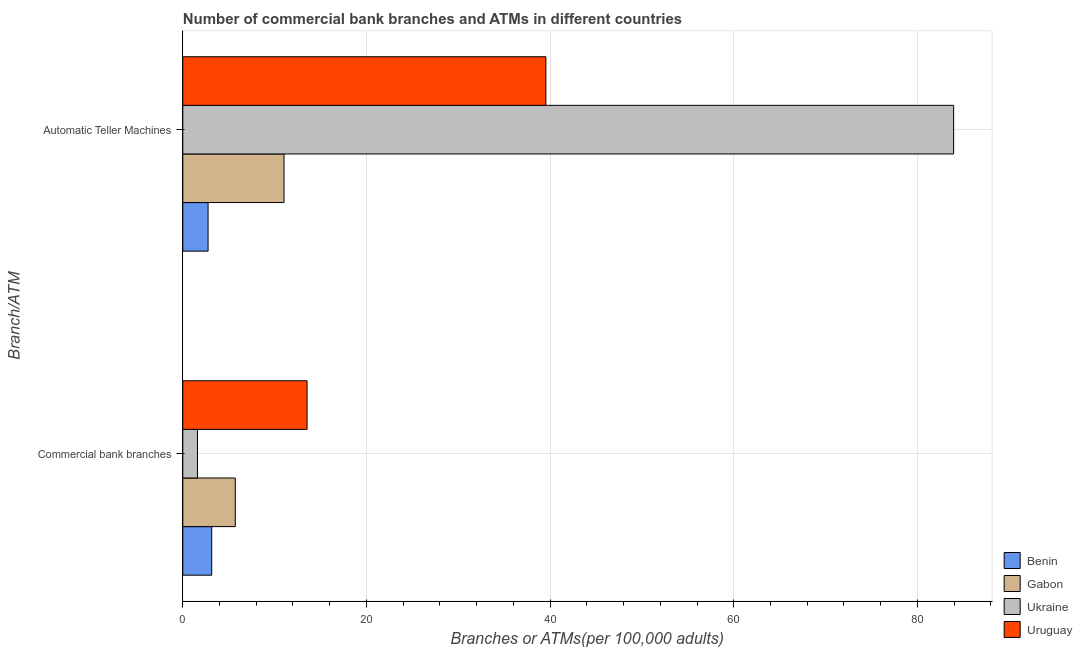How many different coloured bars are there?
Provide a succinct answer. 4. Are the number of bars on each tick of the Y-axis equal?
Keep it short and to the point. Yes. How many bars are there on the 2nd tick from the bottom?
Give a very brief answer. 4. What is the label of the 1st group of bars from the top?
Keep it short and to the point. Automatic Teller Machines. What is the number of atms in Benin?
Give a very brief answer. 2.75. Across all countries, what is the maximum number of atms?
Ensure brevity in your answer.  83.95. Across all countries, what is the minimum number of atms?
Provide a succinct answer. 2.75. In which country was the number of atms maximum?
Make the answer very short. Ukraine. In which country was the number of commercal bank branches minimum?
Your answer should be compact. Ukraine. What is the total number of commercal bank branches in the graph?
Your answer should be compact. 24. What is the difference between the number of atms in Gabon and that in Ukraine?
Give a very brief answer. -72.92. What is the difference between the number of atms in Benin and the number of commercal bank branches in Gabon?
Keep it short and to the point. -2.96. What is the average number of commercal bank branches per country?
Your answer should be very brief. 6. What is the difference between the number of commercal bank branches and number of atms in Uruguay?
Provide a short and direct response. -26.01. What is the ratio of the number of atms in Uruguay to that in Benin?
Offer a terse response. 14.36. Is the number of atms in Ukraine less than that in Uruguay?
Provide a short and direct response. No. What does the 3rd bar from the top in Commercial bank branches represents?
Keep it short and to the point. Gabon. What does the 4th bar from the bottom in Automatic Teller Machines represents?
Offer a terse response. Uruguay. How many bars are there?
Offer a very short reply. 8. Are all the bars in the graph horizontal?
Your response must be concise. Yes. How many countries are there in the graph?
Give a very brief answer. 4. What is the difference between two consecutive major ticks on the X-axis?
Provide a short and direct response. 20. Does the graph contain grids?
Your response must be concise. Yes. What is the title of the graph?
Ensure brevity in your answer.  Number of commercial bank branches and ATMs in different countries. What is the label or title of the X-axis?
Provide a succinct answer. Branches or ATMs(per 100,0 adults). What is the label or title of the Y-axis?
Your answer should be very brief. Branch/ATM. What is the Branches or ATMs(per 100,000 adults) of Benin in Commercial bank branches?
Offer a terse response. 3.15. What is the Branches or ATMs(per 100,000 adults) in Gabon in Commercial bank branches?
Offer a very short reply. 5.72. What is the Branches or ATMs(per 100,000 adults) in Ukraine in Commercial bank branches?
Your answer should be very brief. 1.6. What is the Branches or ATMs(per 100,000 adults) in Uruguay in Commercial bank branches?
Offer a terse response. 13.54. What is the Branches or ATMs(per 100,000 adults) in Benin in Automatic Teller Machines?
Keep it short and to the point. 2.75. What is the Branches or ATMs(per 100,000 adults) of Gabon in Automatic Teller Machines?
Offer a very short reply. 11.03. What is the Branches or ATMs(per 100,000 adults) in Ukraine in Automatic Teller Machines?
Make the answer very short. 83.95. What is the Branches or ATMs(per 100,000 adults) of Uruguay in Automatic Teller Machines?
Give a very brief answer. 39.54. Across all Branch/ATM, what is the maximum Branches or ATMs(per 100,000 adults) of Benin?
Offer a very short reply. 3.15. Across all Branch/ATM, what is the maximum Branches or ATMs(per 100,000 adults) of Gabon?
Offer a very short reply. 11.03. Across all Branch/ATM, what is the maximum Branches or ATMs(per 100,000 adults) of Ukraine?
Offer a terse response. 83.95. Across all Branch/ATM, what is the maximum Branches or ATMs(per 100,000 adults) in Uruguay?
Your answer should be compact. 39.54. Across all Branch/ATM, what is the minimum Branches or ATMs(per 100,000 adults) in Benin?
Your answer should be very brief. 2.75. Across all Branch/ATM, what is the minimum Branches or ATMs(per 100,000 adults) of Gabon?
Your answer should be very brief. 5.72. Across all Branch/ATM, what is the minimum Branches or ATMs(per 100,000 adults) of Ukraine?
Offer a terse response. 1.6. Across all Branch/ATM, what is the minimum Branches or ATMs(per 100,000 adults) of Uruguay?
Your answer should be very brief. 13.54. What is the total Branches or ATMs(per 100,000 adults) in Benin in the graph?
Offer a terse response. 5.9. What is the total Branches or ATMs(per 100,000 adults) in Gabon in the graph?
Provide a succinct answer. 16.74. What is the total Branches or ATMs(per 100,000 adults) in Ukraine in the graph?
Ensure brevity in your answer.  85.54. What is the total Branches or ATMs(per 100,000 adults) in Uruguay in the graph?
Offer a very short reply. 53.08. What is the difference between the Branches or ATMs(per 100,000 adults) in Benin in Commercial bank branches and that in Automatic Teller Machines?
Offer a very short reply. 0.4. What is the difference between the Branches or ATMs(per 100,000 adults) of Gabon in Commercial bank branches and that in Automatic Teller Machines?
Make the answer very short. -5.31. What is the difference between the Branches or ATMs(per 100,000 adults) in Ukraine in Commercial bank branches and that in Automatic Teller Machines?
Provide a short and direct response. -82.35. What is the difference between the Branches or ATMs(per 100,000 adults) of Uruguay in Commercial bank branches and that in Automatic Teller Machines?
Your answer should be very brief. -26.01. What is the difference between the Branches or ATMs(per 100,000 adults) of Benin in Commercial bank branches and the Branches or ATMs(per 100,000 adults) of Gabon in Automatic Teller Machines?
Provide a succinct answer. -7.88. What is the difference between the Branches or ATMs(per 100,000 adults) in Benin in Commercial bank branches and the Branches or ATMs(per 100,000 adults) in Ukraine in Automatic Teller Machines?
Offer a terse response. -80.8. What is the difference between the Branches or ATMs(per 100,000 adults) in Benin in Commercial bank branches and the Branches or ATMs(per 100,000 adults) in Uruguay in Automatic Teller Machines?
Provide a short and direct response. -36.39. What is the difference between the Branches or ATMs(per 100,000 adults) of Gabon in Commercial bank branches and the Branches or ATMs(per 100,000 adults) of Ukraine in Automatic Teller Machines?
Provide a succinct answer. -78.23. What is the difference between the Branches or ATMs(per 100,000 adults) in Gabon in Commercial bank branches and the Branches or ATMs(per 100,000 adults) in Uruguay in Automatic Teller Machines?
Your answer should be compact. -33.83. What is the difference between the Branches or ATMs(per 100,000 adults) in Ukraine in Commercial bank branches and the Branches or ATMs(per 100,000 adults) in Uruguay in Automatic Teller Machines?
Offer a terse response. -37.95. What is the average Branches or ATMs(per 100,000 adults) in Benin per Branch/ATM?
Keep it short and to the point. 2.95. What is the average Branches or ATMs(per 100,000 adults) of Gabon per Branch/ATM?
Make the answer very short. 8.37. What is the average Branches or ATMs(per 100,000 adults) of Ukraine per Branch/ATM?
Provide a succinct answer. 42.77. What is the average Branches or ATMs(per 100,000 adults) of Uruguay per Branch/ATM?
Ensure brevity in your answer.  26.54. What is the difference between the Branches or ATMs(per 100,000 adults) of Benin and Branches or ATMs(per 100,000 adults) of Gabon in Commercial bank branches?
Keep it short and to the point. -2.57. What is the difference between the Branches or ATMs(per 100,000 adults) of Benin and Branches or ATMs(per 100,000 adults) of Ukraine in Commercial bank branches?
Keep it short and to the point. 1.55. What is the difference between the Branches or ATMs(per 100,000 adults) in Benin and Branches or ATMs(per 100,000 adults) in Uruguay in Commercial bank branches?
Your response must be concise. -10.39. What is the difference between the Branches or ATMs(per 100,000 adults) of Gabon and Branches or ATMs(per 100,000 adults) of Ukraine in Commercial bank branches?
Your answer should be very brief. 4.12. What is the difference between the Branches or ATMs(per 100,000 adults) of Gabon and Branches or ATMs(per 100,000 adults) of Uruguay in Commercial bank branches?
Your answer should be very brief. -7.82. What is the difference between the Branches or ATMs(per 100,000 adults) of Ukraine and Branches or ATMs(per 100,000 adults) of Uruguay in Commercial bank branches?
Offer a terse response. -11.94. What is the difference between the Branches or ATMs(per 100,000 adults) in Benin and Branches or ATMs(per 100,000 adults) in Gabon in Automatic Teller Machines?
Ensure brevity in your answer.  -8.27. What is the difference between the Branches or ATMs(per 100,000 adults) in Benin and Branches or ATMs(per 100,000 adults) in Ukraine in Automatic Teller Machines?
Provide a succinct answer. -81.19. What is the difference between the Branches or ATMs(per 100,000 adults) in Benin and Branches or ATMs(per 100,000 adults) in Uruguay in Automatic Teller Machines?
Give a very brief answer. -36.79. What is the difference between the Branches or ATMs(per 100,000 adults) of Gabon and Branches or ATMs(per 100,000 adults) of Ukraine in Automatic Teller Machines?
Ensure brevity in your answer.  -72.92. What is the difference between the Branches or ATMs(per 100,000 adults) of Gabon and Branches or ATMs(per 100,000 adults) of Uruguay in Automatic Teller Machines?
Provide a short and direct response. -28.52. What is the difference between the Branches or ATMs(per 100,000 adults) of Ukraine and Branches or ATMs(per 100,000 adults) of Uruguay in Automatic Teller Machines?
Provide a short and direct response. 44.4. What is the ratio of the Branches or ATMs(per 100,000 adults) in Benin in Commercial bank branches to that in Automatic Teller Machines?
Make the answer very short. 1.14. What is the ratio of the Branches or ATMs(per 100,000 adults) in Gabon in Commercial bank branches to that in Automatic Teller Machines?
Make the answer very short. 0.52. What is the ratio of the Branches or ATMs(per 100,000 adults) of Ukraine in Commercial bank branches to that in Automatic Teller Machines?
Make the answer very short. 0.02. What is the ratio of the Branches or ATMs(per 100,000 adults) of Uruguay in Commercial bank branches to that in Automatic Teller Machines?
Provide a short and direct response. 0.34. What is the difference between the highest and the second highest Branches or ATMs(per 100,000 adults) in Benin?
Keep it short and to the point. 0.4. What is the difference between the highest and the second highest Branches or ATMs(per 100,000 adults) in Gabon?
Your response must be concise. 5.31. What is the difference between the highest and the second highest Branches or ATMs(per 100,000 adults) in Ukraine?
Give a very brief answer. 82.35. What is the difference between the highest and the second highest Branches or ATMs(per 100,000 adults) of Uruguay?
Offer a very short reply. 26.01. What is the difference between the highest and the lowest Branches or ATMs(per 100,000 adults) in Benin?
Offer a terse response. 0.4. What is the difference between the highest and the lowest Branches or ATMs(per 100,000 adults) of Gabon?
Provide a short and direct response. 5.31. What is the difference between the highest and the lowest Branches or ATMs(per 100,000 adults) in Ukraine?
Ensure brevity in your answer.  82.35. What is the difference between the highest and the lowest Branches or ATMs(per 100,000 adults) in Uruguay?
Make the answer very short. 26.01. 